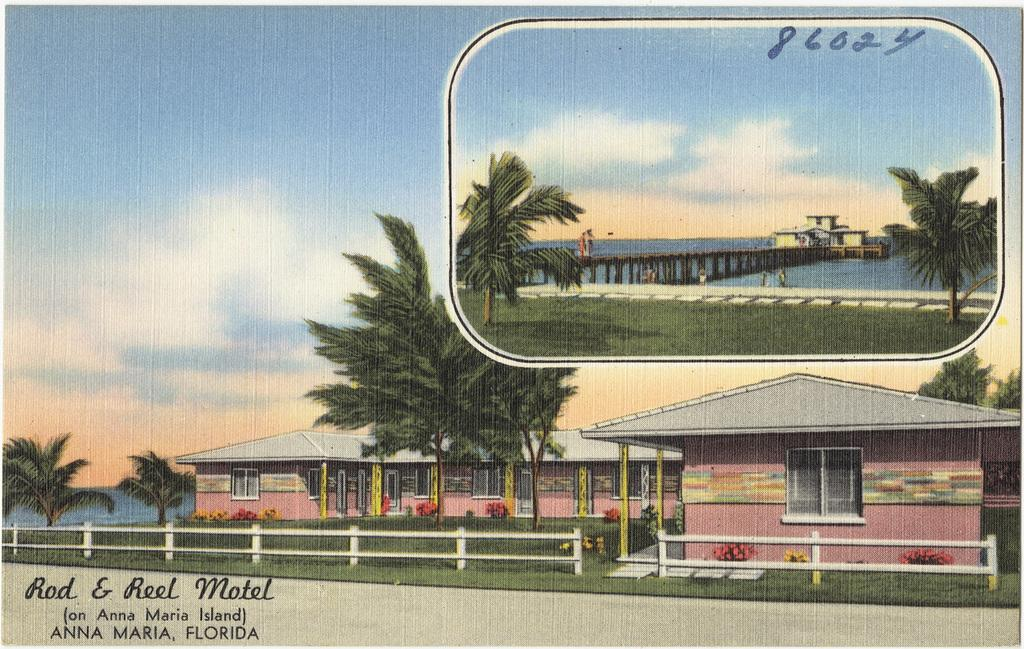What type of structures can be seen in the image? There are houses in the image. What is located in front of the houses? Trees are visible in front of the houses. What part of the natural environment is visible in the image? The sky is visible in the image. What architectural feature is present in the image? There is a bridge in the image. What body of water is present in the image? A lake is present in the image. What action can be seen being performed by the lake in the image? The lake is a body of water and does not perform actions in the image. 